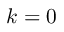Convert formula to latex. <formula><loc_0><loc_0><loc_500><loc_500>k = 0</formula> 